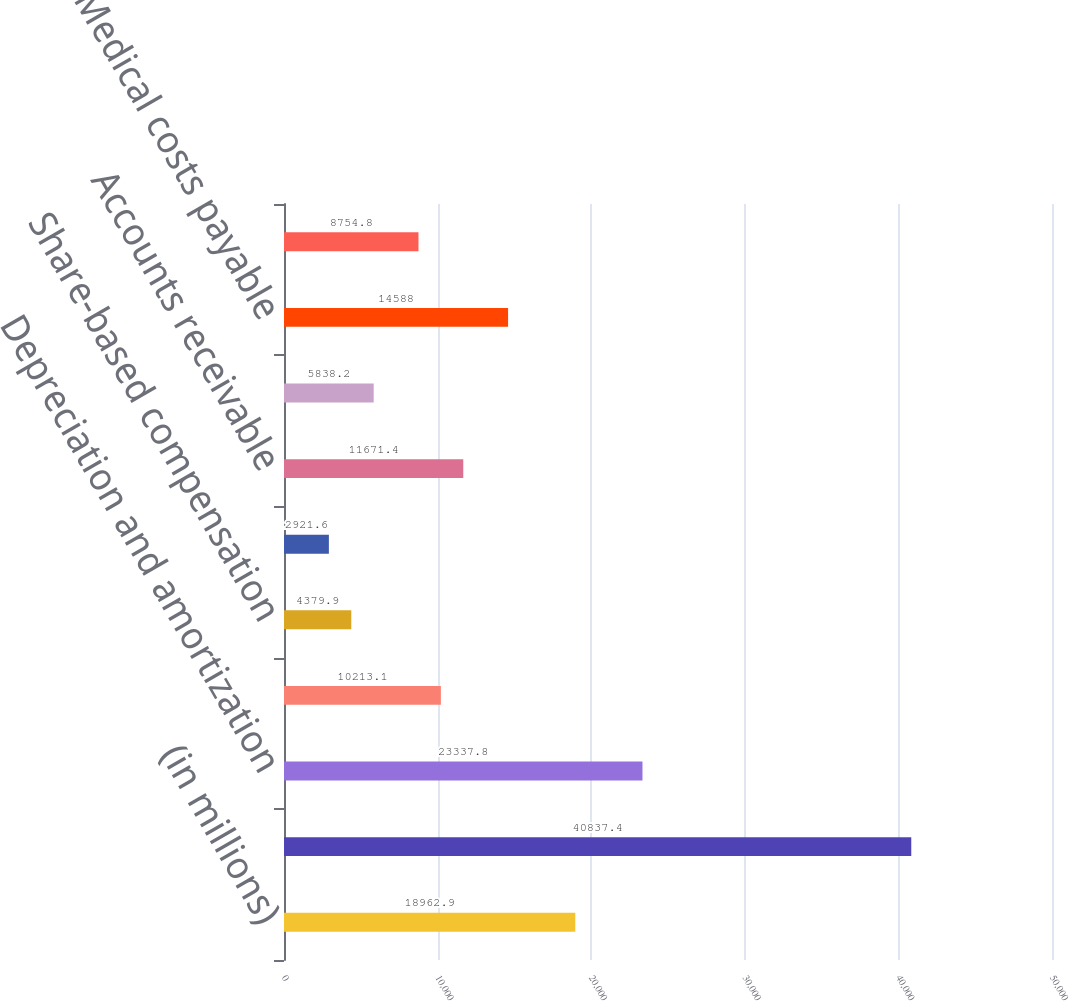<chart> <loc_0><loc_0><loc_500><loc_500><bar_chart><fcel>(in millions)<fcel>Net earnings<fcel>Depreciation and amortization<fcel>Deferred income taxes<fcel>Share-based compensation<fcel>Other net<fcel>Accounts receivable<fcel>Other assets<fcel>Medical costs payable<fcel>Accounts payable and other<nl><fcel>18962.9<fcel>40837.4<fcel>23337.8<fcel>10213.1<fcel>4379.9<fcel>2921.6<fcel>11671.4<fcel>5838.2<fcel>14588<fcel>8754.8<nl></chart> 